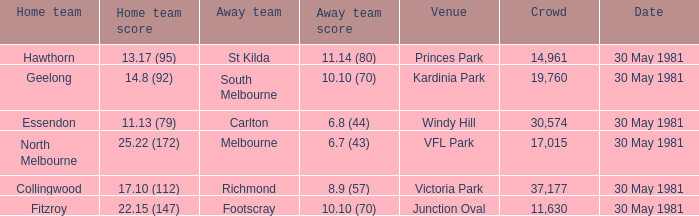What did carlton score while away? 6.8 (44). 